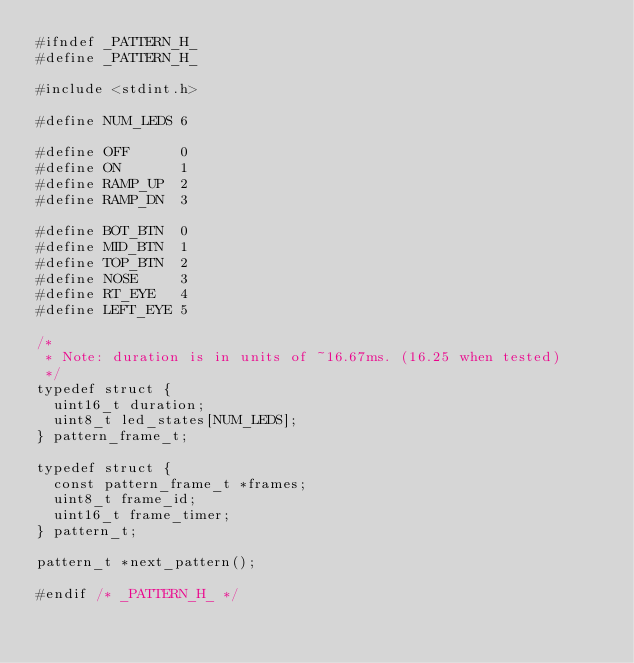<code> <loc_0><loc_0><loc_500><loc_500><_C_>#ifndef _PATTERN_H_
#define _PATTERN_H_

#include <stdint.h>

#define NUM_LEDS 6

#define OFF      0
#define ON       1
#define RAMP_UP  2
#define RAMP_DN  3

#define BOT_BTN  0
#define MID_BTN  1
#define TOP_BTN  2
#define NOSE     3
#define RT_EYE   4
#define LEFT_EYE 5

/*
 * Note: duration is in units of ~16.67ms. (16.25 when tested)
 */
typedef struct {
  uint16_t duration;
  uint8_t led_states[NUM_LEDS];
} pattern_frame_t;

typedef struct {
  const pattern_frame_t *frames;
  uint8_t frame_id;
  uint16_t frame_timer;
} pattern_t;

pattern_t *next_pattern();

#endif /* _PATTERN_H_ */
</code> 